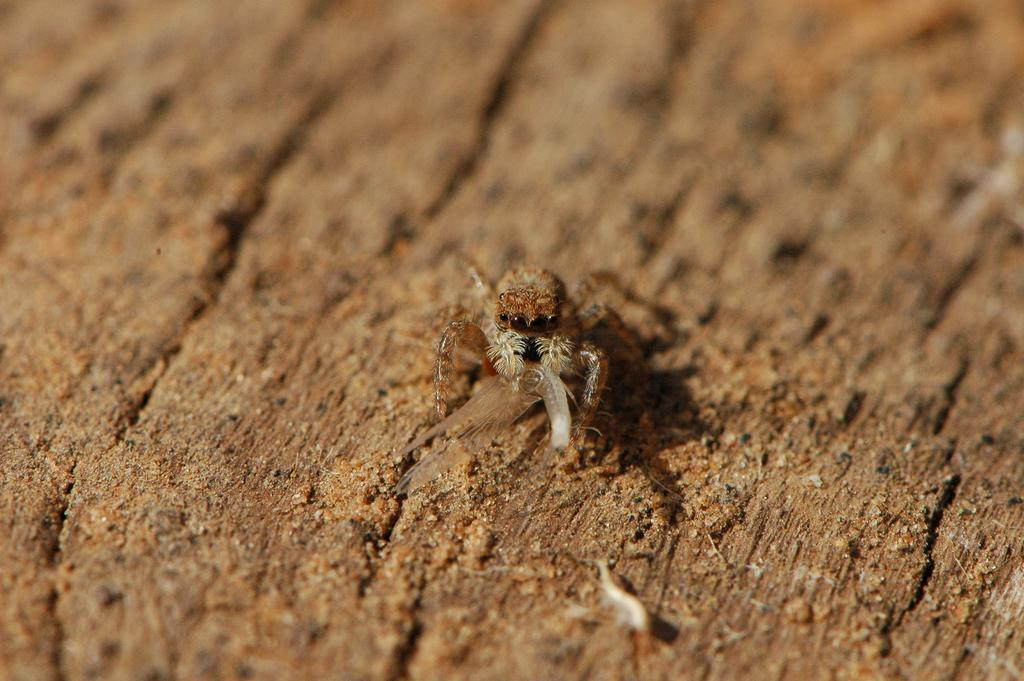What type of creature can be seen in the image? There is an insect in the image. What is the insect doing in the image? The insect is holding a worm. Are there any other worms visible in the image? Yes, there is another worm on the ground in the image. What type of bears can be seen in the image? There are no bears present in the image; it features an insect holding a worm and another worm on the ground. How does the deer interact with the insect in the image? There is no deer present in the image, so it cannot interact with the insect. 